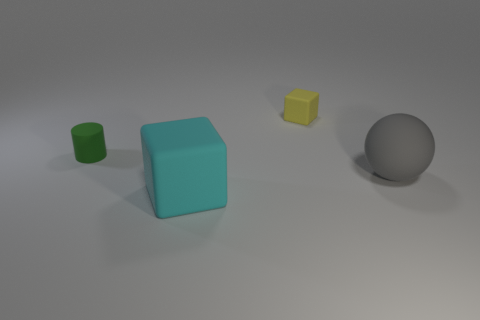There is a thing behind the small green cylinder; what is its shape?
Offer a very short reply. Cube. What number of yellow objects are either tiny objects or cylinders?
Give a very brief answer. 1. Does the tiny green thing have the same material as the small block?
Offer a terse response. Yes. How many gray balls are right of the small green matte object?
Your response must be concise. 1. The object that is both in front of the tiny green matte thing and behind the large cube is made of what material?
Your answer should be compact. Rubber. What number of blocks are big cyan objects or small green things?
Provide a succinct answer. 1. There is another large thing that is the same shape as the yellow object; what is it made of?
Provide a succinct answer. Rubber. What is the size of the cyan cube that is the same material as the sphere?
Your answer should be very brief. Large. Does the big matte object to the left of the big gray matte ball have the same shape as the thing that is right of the small yellow rubber cube?
Provide a succinct answer. No. The small cylinder that is the same material as the tiny yellow cube is what color?
Keep it short and to the point. Green. 